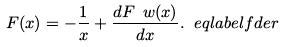Convert formula to latex. <formula><loc_0><loc_0><loc_500><loc_500>F ( x ) = - \frac { 1 } { x } + \frac { d F _ { \ } w ( x ) } { d x } . \ e q l a b e l { f d e r }</formula> 